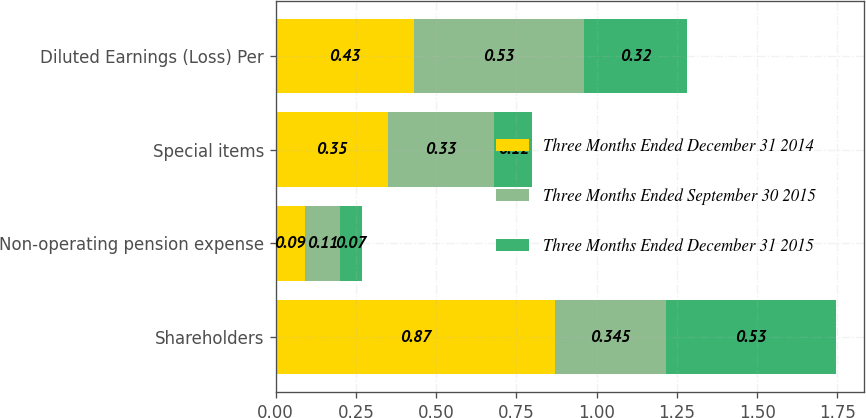<chart> <loc_0><loc_0><loc_500><loc_500><stacked_bar_chart><ecel><fcel>Shareholders<fcel>Non-operating pension expense<fcel>Special items<fcel>Diluted Earnings (Loss) Per<nl><fcel>Three Months Ended December 31 2014<fcel>0.87<fcel>0.09<fcel>0.35<fcel>0.43<nl><fcel>Three Months Ended September 30 2015<fcel>0.345<fcel>0.11<fcel>0.33<fcel>0.53<nl><fcel>Three Months Ended December 31 2015<fcel>0.53<fcel>0.07<fcel>0.12<fcel>0.32<nl></chart> 